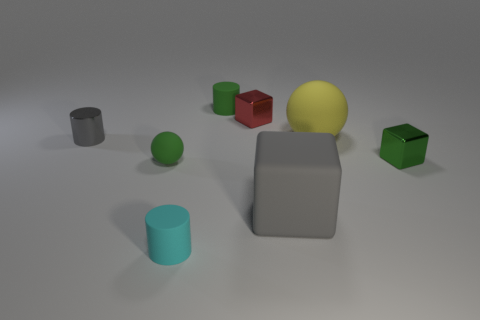How many objects are there in total, and can you categorize them by color? In the image, there are a total of six objects. They can be categorized by color as follows: one yellow sphere, one green cube, one red cube, one cyan cylinder, one gray cylinder, and one gray block.  Which object stands out the most to you and why? The yellow sphere stands out the most due to its bright color, which contrasts with the relatively muted tones of the other objects, and its spherical shape, which differentiates it from the angular shapes of the cubes and the cylindrical shapes. 